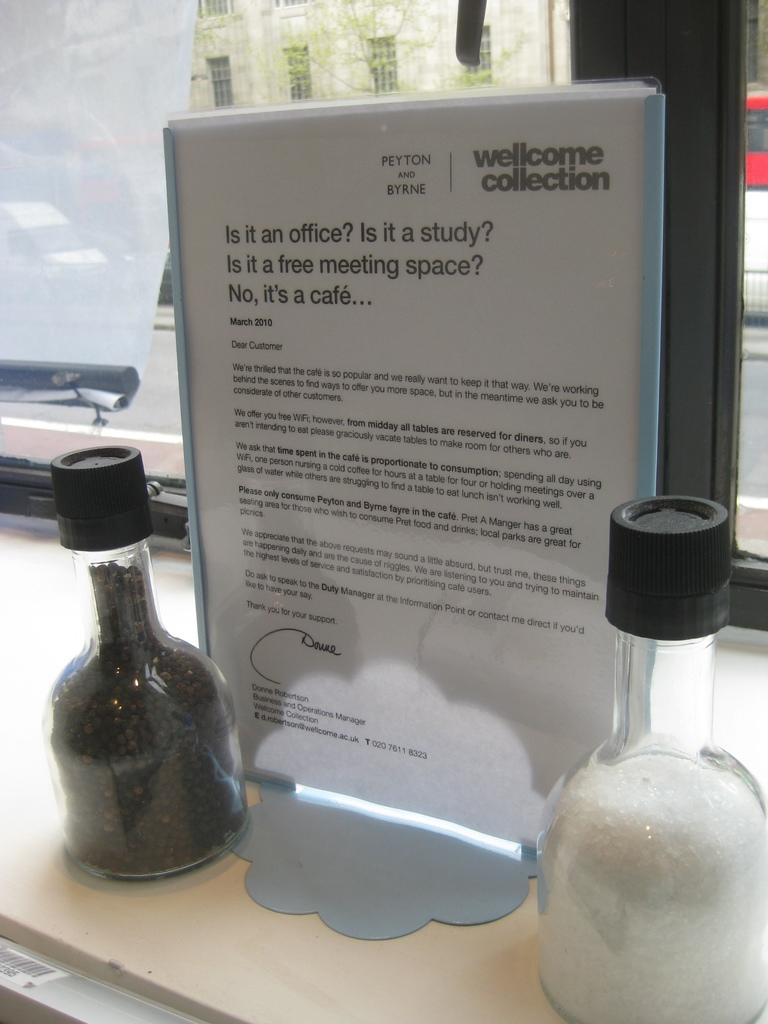Provide a one-sentence caption for the provided image. A display sign welcomes people to Peyton and Byrnes cafe. 